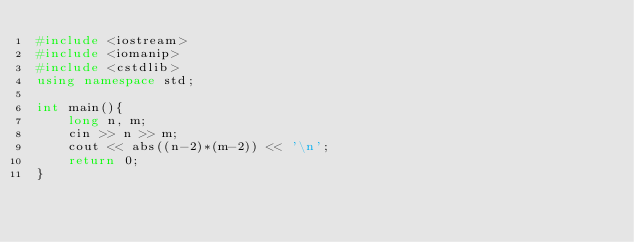Convert code to text. <code><loc_0><loc_0><loc_500><loc_500><_C++_>#include <iostream>
#include <iomanip>
#include <cstdlib>
using namespace std;

int main(){
    long n, m;
    cin >> n >> m;
    cout << abs((n-2)*(m-2)) << '\n';
    return 0;
}</code> 